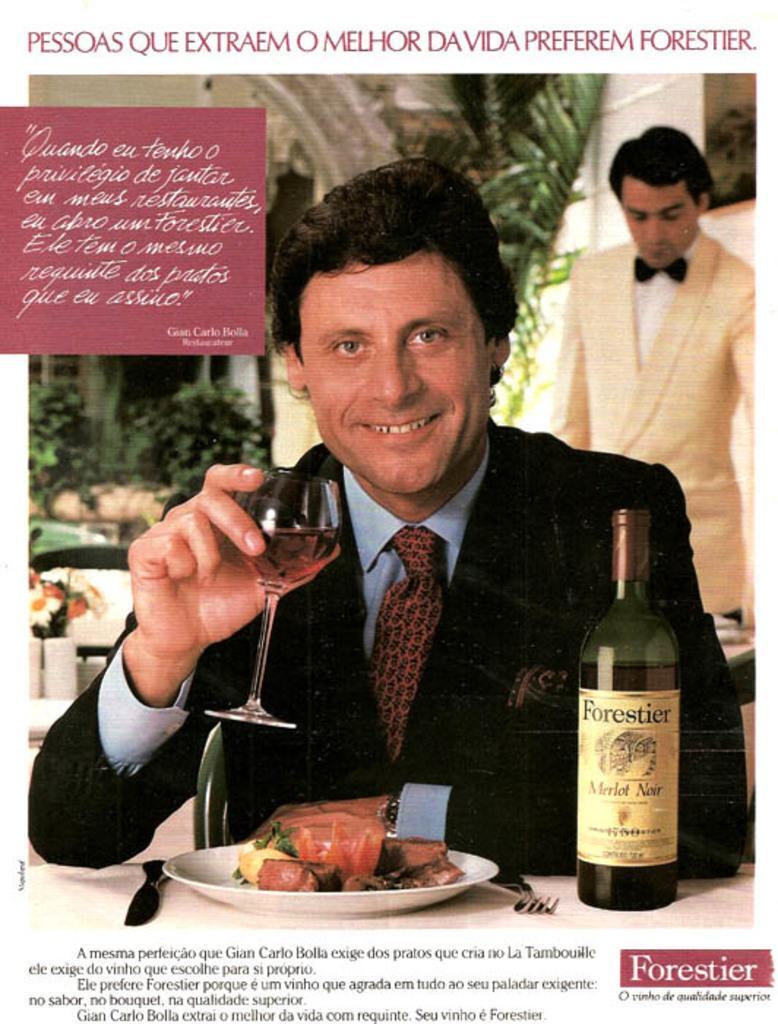Describe this image in one or two sentences. This is a picture of a picture, a person sit on the chair and holding a glass and contain a drink and in front of him there a table ,on the table there is a a plate ,on the plate there is a food and a bottle kept on the table ,back side of him there is a person stand. beside him there is a tree 